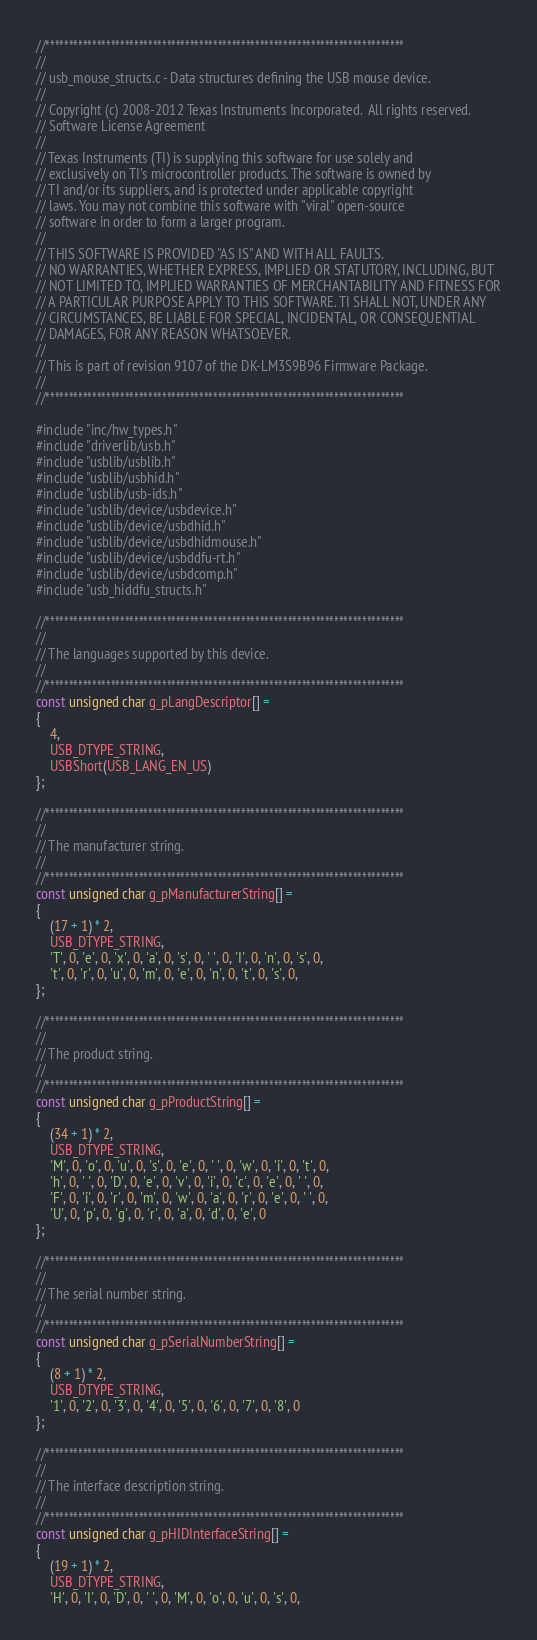<code> <loc_0><loc_0><loc_500><loc_500><_C_>//*****************************************************************************
//
// usb_mouse_structs.c - Data structures defining the USB mouse device.
//
// Copyright (c) 2008-2012 Texas Instruments Incorporated.  All rights reserved.
// Software License Agreement
// 
// Texas Instruments (TI) is supplying this software for use solely and
// exclusively on TI's microcontroller products. The software is owned by
// TI and/or its suppliers, and is protected under applicable copyright
// laws. You may not combine this software with "viral" open-source
// software in order to form a larger program.
// 
// THIS SOFTWARE IS PROVIDED "AS IS" AND WITH ALL FAULTS.
// NO WARRANTIES, WHETHER EXPRESS, IMPLIED OR STATUTORY, INCLUDING, BUT
// NOT LIMITED TO, IMPLIED WARRANTIES OF MERCHANTABILITY AND FITNESS FOR
// A PARTICULAR PURPOSE APPLY TO THIS SOFTWARE. TI SHALL NOT, UNDER ANY
// CIRCUMSTANCES, BE LIABLE FOR SPECIAL, INCIDENTAL, OR CONSEQUENTIAL
// DAMAGES, FOR ANY REASON WHATSOEVER.
// 
// This is part of revision 9107 of the DK-LM3S9B96 Firmware Package.
//
//*****************************************************************************

#include "inc/hw_types.h"
#include "driverlib/usb.h"
#include "usblib/usblib.h"
#include "usblib/usbhid.h"
#include "usblib/usb-ids.h"
#include "usblib/device/usbdevice.h"
#include "usblib/device/usbdhid.h"
#include "usblib/device/usbdhidmouse.h"
#include "usblib/device/usbddfu-rt.h"
#include "usblib/device/usbdcomp.h"
#include "usb_hiddfu_structs.h"

//*****************************************************************************
//
// The languages supported by this device.
//
//*****************************************************************************
const unsigned char g_pLangDescriptor[] =
{
    4,
    USB_DTYPE_STRING,
    USBShort(USB_LANG_EN_US)
};

//*****************************************************************************
//
// The manufacturer string.
//
//*****************************************************************************
const unsigned char g_pManufacturerString[] =
{
    (17 + 1) * 2,
    USB_DTYPE_STRING,
    'T', 0, 'e', 0, 'x', 0, 'a', 0, 's', 0, ' ', 0, 'I', 0, 'n', 0, 's', 0,
    't', 0, 'r', 0, 'u', 0, 'm', 0, 'e', 0, 'n', 0, 't', 0, 's', 0,
};

//*****************************************************************************
//
// The product string.
//
//*****************************************************************************
const unsigned char g_pProductString[] =
{
    (34 + 1) * 2,
    USB_DTYPE_STRING,
    'M', 0, 'o', 0, 'u', 0, 's', 0, 'e', 0, ' ', 0, 'w', 0, 'i', 0, 't', 0,
    'h', 0, ' ', 0, 'D', 0, 'e', 0, 'v', 0, 'i', 0, 'c', 0, 'e', 0, ' ', 0,
    'F', 0, 'i', 0, 'r', 0, 'm', 0, 'w', 0, 'a', 0, 'r', 0, 'e', 0, ' ', 0,
    'U', 0, 'p', 0, 'g', 0, 'r', 0, 'a', 0, 'd', 0, 'e', 0
};

//*****************************************************************************
//
// The serial number string.
//
//*****************************************************************************
const unsigned char g_pSerialNumberString[] =
{
    (8 + 1) * 2,
    USB_DTYPE_STRING,
    '1', 0, '2', 0, '3', 0, '4', 0, '5', 0, '6', 0, '7', 0, '8', 0
};

//*****************************************************************************
//
// The interface description string.
//
//*****************************************************************************
const unsigned char g_pHIDInterfaceString[] =
{
    (19 + 1) * 2,
    USB_DTYPE_STRING,
    'H', 0, 'I', 0, 'D', 0, ' ', 0, 'M', 0, 'o', 0, 'u', 0, 's', 0,</code> 